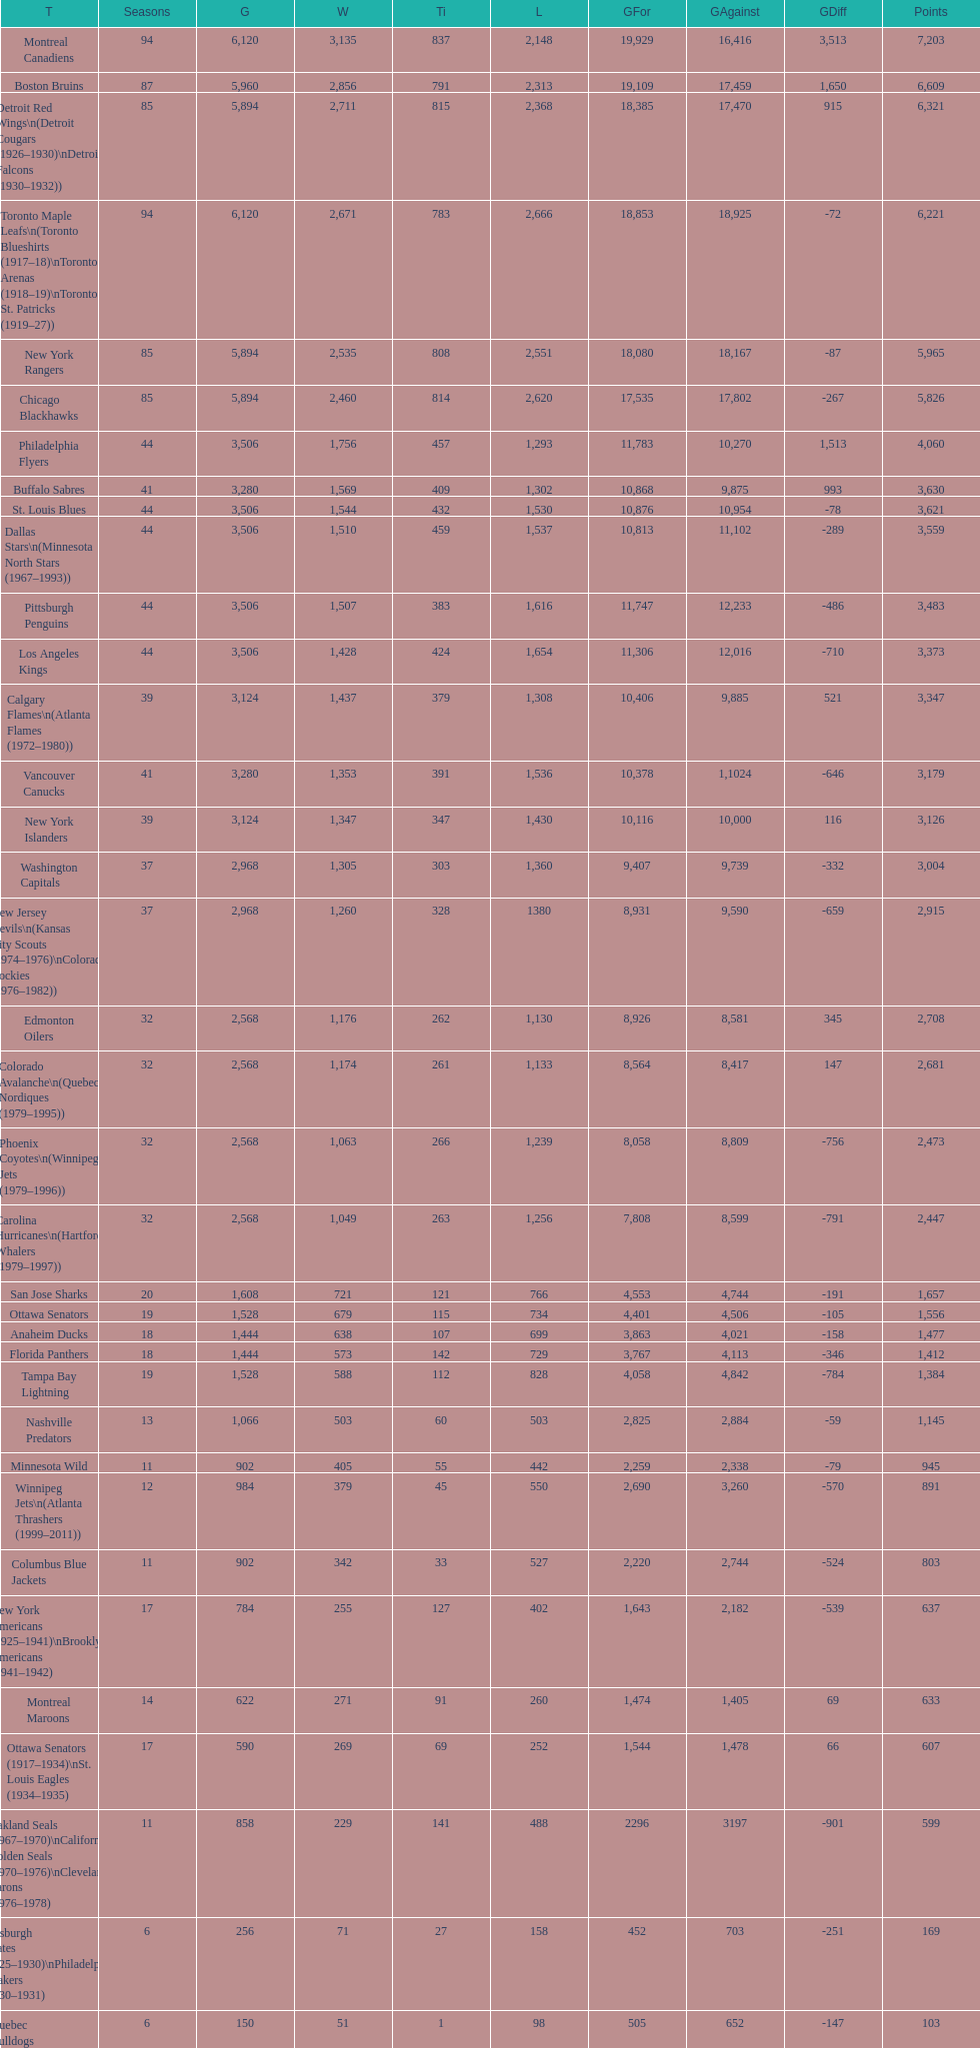How many total points has the lost angeles kings scored? 3,373. 